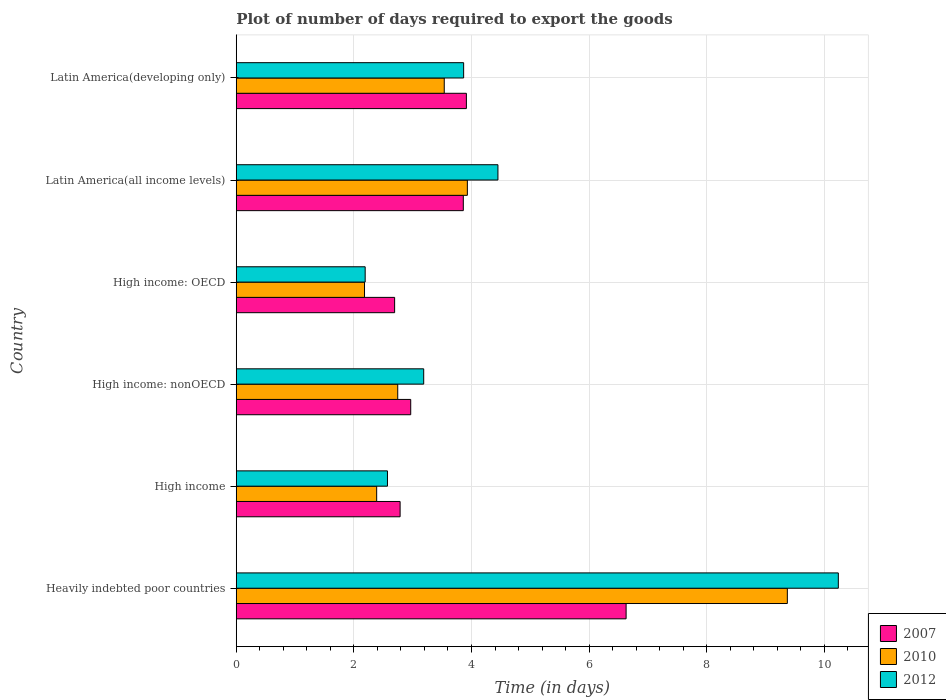How many groups of bars are there?
Make the answer very short. 6. Are the number of bars per tick equal to the number of legend labels?
Provide a short and direct response. Yes. What is the label of the 2nd group of bars from the top?
Your answer should be compact. Latin America(all income levels). What is the time required to export goods in 2012 in High income: nonOECD?
Offer a terse response. 3.19. Across all countries, what is the maximum time required to export goods in 2010?
Give a very brief answer. 9.37. Across all countries, what is the minimum time required to export goods in 2012?
Make the answer very short. 2.19. In which country was the time required to export goods in 2010 maximum?
Your response must be concise. Heavily indebted poor countries. In which country was the time required to export goods in 2010 minimum?
Your answer should be compact. High income: OECD. What is the total time required to export goods in 2010 in the graph?
Offer a terse response. 24.15. What is the difference between the time required to export goods in 2010 in Heavily indebted poor countries and that in Latin America(developing only)?
Make the answer very short. 5.83. What is the difference between the time required to export goods in 2012 in High income: OECD and the time required to export goods in 2007 in Latin America(all income levels)?
Keep it short and to the point. -1.67. What is the average time required to export goods in 2007 per country?
Keep it short and to the point. 3.81. What is the difference between the time required to export goods in 2010 and time required to export goods in 2007 in High income?
Your response must be concise. -0.4. What is the ratio of the time required to export goods in 2007 in High income to that in Latin America(developing only)?
Your response must be concise. 0.71. Is the time required to export goods in 2010 in High income: nonOECD less than that in Latin America(all income levels)?
Provide a succinct answer. Yes. What is the difference between the highest and the second highest time required to export goods in 2010?
Your answer should be compact. 5.44. What is the difference between the highest and the lowest time required to export goods in 2012?
Keep it short and to the point. 8.05. In how many countries, is the time required to export goods in 2010 greater than the average time required to export goods in 2010 taken over all countries?
Keep it short and to the point. 1. Is the sum of the time required to export goods in 2007 in Heavily indebted poor countries and Latin America(all income levels) greater than the maximum time required to export goods in 2010 across all countries?
Provide a succinct answer. Yes. What does the 2nd bar from the top in Latin America(developing only) represents?
Ensure brevity in your answer.  2010. Is it the case that in every country, the sum of the time required to export goods in 2012 and time required to export goods in 2007 is greater than the time required to export goods in 2010?
Keep it short and to the point. Yes. How many bars are there?
Offer a terse response. 18. Are the values on the major ticks of X-axis written in scientific E-notation?
Your answer should be very brief. No. Does the graph contain any zero values?
Ensure brevity in your answer.  No. Does the graph contain grids?
Provide a short and direct response. Yes. Where does the legend appear in the graph?
Make the answer very short. Bottom right. How are the legend labels stacked?
Your answer should be compact. Vertical. What is the title of the graph?
Make the answer very short. Plot of number of days required to export the goods. What is the label or title of the X-axis?
Your response must be concise. Time (in days). What is the label or title of the Y-axis?
Make the answer very short. Country. What is the Time (in days) of 2007 in Heavily indebted poor countries?
Provide a short and direct response. 6.63. What is the Time (in days) of 2010 in Heavily indebted poor countries?
Make the answer very short. 9.37. What is the Time (in days) of 2012 in Heavily indebted poor countries?
Provide a short and direct response. 10.24. What is the Time (in days) in 2007 in High income?
Your answer should be compact. 2.79. What is the Time (in days) in 2010 in High income?
Your answer should be compact. 2.39. What is the Time (in days) in 2012 in High income?
Provide a succinct answer. 2.57. What is the Time (in days) in 2007 in High income: nonOECD?
Ensure brevity in your answer.  2.97. What is the Time (in days) of 2010 in High income: nonOECD?
Your answer should be very brief. 2.75. What is the Time (in days) of 2012 in High income: nonOECD?
Offer a terse response. 3.19. What is the Time (in days) of 2007 in High income: OECD?
Provide a short and direct response. 2.69. What is the Time (in days) in 2010 in High income: OECD?
Offer a very short reply. 2.18. What is the Time (in days) of 2012 in High income: OECD?
Keep it short and to the point. 2.19. What is the Time (in days) of 2007 in Latin America(all income levels)?
Keep it short and to the point. 3.86. What is the Time (in days) of 2010 in Latin America(all income levels)?
Your response must be concise. 3.93. What is the Time (in days) in 2012 in Latin America(all income levels)?
Offer a terse response. 4.45. What is the Time (in days) of 2007 in Latin America(developing only)?
Give a very brief answer. 3.91. What is the Time (in days) of 2010 in Latin America(developing only)?
Offer a terse response. 3.54. What is the Time (in days) of 2012 in Latin America(developing only)?
Give a very brief answer. 3.87. Across all countries, what is the maximum Time (in days) of 2007?
Provide a succinct answer. 6.63. Across all countries, what is the maximum Time (in days) in 2010?
Give a very brief answer. 9.37. Across all countries, what is the maximum Time (in days) of 2012?
Offer a very short reply. 10.24. Across all countries, what is the minimum Time (in days) of 2007?
Keep it short and to the point. 2.69. Across all countries, what is the minimum Time (in days) in 2010?
Give a very brief answer. 2.18. Across all countries, what is the minimum Time (in days) of 2012?
Your answer should be very brief. 2.19. What is the total Time (in days) of 2007 in the graph?
Your answer should be compact. 22.85. What is the total Time (in days) in 2010 in the graph?
Ensure brevity in your answer.  24.15. What is the total Time (in days) of 2012 in the graph?
Make the answer very short. 26.51. What is the difference between the Time (in days) in 2007 in Heavily indebted poor countries and that in High income?
Ensure brevity in your answer.  3.84. What is the difference between the Time (in days) of 2010 in Heavily indebted poor countries and that in High income?
Make the answer very short. 6.98. What is the difference between the Time (in days) of 2012 in Heavily indebted poor countries and that in High income?
Ensure brevity in your answer.  7.67. What is the difference between the Time (in days) of 2007 in Heavily indebted poor countries and that in High income: nonOECD?
Ensure brevity in your answer.  3.66. What is the difference between the Time (in days) of 2010 in Heavily indebted poor countries and that in High income: nonOECD?
Keep it short and to the point. 6.63. What is the difference between the Time (in days) of 2012 in Heavily indebted poor countries and that in High income: nonOECD?
Your response must be concise. 7.05. What is the difference between the Time (in days) in 2007 in Heavily indebted poor countries and that in High income: OECD?
Provide a short and direct response. 3.94. What is the difference between the Time (in days) in 2010 in Heavily indebted poor countries and that in High income: OECD?
Give a very brief answer. 7.19. What is the difference between the Time (in days) of 2012 in Heavily indebted poor countries and that in High income: OECD?
Offer a very short reply. 8.05. What is the difference between the Time (in days) of 2007 in Heavily indebted poor countries and that in Latin America(all income levels)?
Keep it short and to the point. 2.77. What is the difference between the Time (in days) of 2010 in Heavily indebted poor countries and that in Latin America(all income levels)?
Your answer should be compact. 5.44. What is the difference between the Time (in days) of 2012 in Heavily indebted poor countries and that in Latin America(all income levels)?
Provide a short and direct response. 5.79. What is the difference between the Time (in days) in 2007 in Heavily indebted poor countries and that in Latin America(developing only)?
Give a very brief answer. 2.72. What is the difference between the Time (in days) in 2010 in Heavily indebted poor countries and that in Latin America(developing only)?
Provide a succinct answer. 5.83. What is the difference between the Time (in days) of 2012 in Heavily indebted poor countries and that in Latin America(developing only)?
Keep it short and to the point. 6.37. What is the difference between the Time (in days) of 2007 in High income and that in High income: nonOECD?
Give a very brief answer. -0.18. What is the difference between the Time (in days) in 2010 in High income and that in High income: nonOECD?
Your answer should be very brief. -0.36. What is the difference between the Time (in days) in 2012 in High income and that in High income: nonOECD?
Your answer should be compact. -0.62. What is the difference between the Time (in days) in 2007 in High income and that in High income: OECD?
Provide a short and direct response. 0.09. What is the difference between the Time (in days) in 2010 in High income and that in High income: OECD?
Keep it short and to the point. 0.21. What is the difference between the Time (in days) in 2012 in High income and that in High income: OECD?
Your response must be concise. 0.38. What is the difference between the Time (in days) of 2007 in High income and that in Latin America(all income levels)?
Your response must be concise. -1.07. What is the difference between the Time (in days) in 2010 in High income and that in Latin America(all income levels)?
Ensure brevity in your answer.  -1.54. What is the difference between the Time (in days) of 2012 in High income and that in Latin America(all income levels)?
Keep it short and to the point. -1.88. What is the difference between the Time (in days) in 2007 in High income and that in Latin America(developing only)?
Ensure brevity in your answer.  -1.13. What is the difference between the Time (in days) in 2010 in High income and that in Latin America(developing only)?
Offer a terse response. -1.15. What is the difference between the Time (in days) in 2012 in High income and that in Latin America(developing only)?
Ensure brevity in your answer.  -1.3. What is the difference between the Time (in days) of 2007 in High income: nonOECD and that in High income: OECD?
Ensure brevity in your answer.  0.27. What is the difference between the Time (in days) in 2010 in High income: nonOECD and that in High income: OECD?
Your response must be concise. 0.56. What is the difference between the Time (in days) in 2012 in High income: nonOECD and that in High income: OECD?
Provide a succinct answer. 1. What is the difference between the Time (in days) in 2007 in High income: nonOECD and that in Latin America(all income levels)?
Your response must be concise. -0.89. What is the difference between the Time (in days) in 2010 in High income: nonOECD and that in Latin America(all income levels)?
Make the answer very short. -1.18. What is the difference between the Time (in days) of 2012 in High income: nonOECD and that in Latin America(all income levels)?
Your response must be concise. -1.26. What is the difference between the Time (in days) in 2007 in High income: nonOECD and that in Latin America(developing only)?
Ensure brevity in your answer.  -0.95. What is the difference between the Time (in days) of 2010 in High income: nonOECD and that in Latin America(developing only)?
Provide a short and direct response. -0.79. What is the difference between the Time (in days) in 2012 in High income: nonOECD and that in Latin America(developing only)?
Give a very brief answer. -0.68. What is the difference between the Time (in days) of 2007 in High income: OECD and that in Latin America(all income levels)?
Give a very brief answer. -1.17. What is the difference between the Time (in days) of 2010 in High income: OECD and that in Latin America(all income levels)?
Make the answer very short. -1.75. What is the difference between the Time (in days) of 2012 in High income: OECD and that in Latin America(all income levels)?
Your response must be concise. -2.26. What is the difference between the Time (in days) of 2007 in High income: OECD and that in Latin America(developing only)?
Offer a terse response. -1.22. What is the difference between the Time (in days) in 2010 in High income: OECD and that in Latin America(developing only)?
Offer a terse response. -1.36. What is the difference between the Time (in days) of 2012 in High income: OECD and that in Latin America(developing only)?
Ensure brevity in your answer.  -1.67. What is the difference between the Time (in days) in 2007 in Latin America(all income levels) and that in Latin America(developing only)?
Give a very brief answer. -0.05. What is the difference between the Time (in days) in 2010 in Latin America(all income levels) and that in Latin America(developing only)?
Your answer should be very brief. 0.39. What is the difference between the Time (in days) in 2012 in Latin America(all income levels) and that in Latin America(developing only)?
Provide a short and direct response. 0.58. What is the difference between the Time (in days) of 2007 in Heavily indebted poor countries and the Time (in days) of 2010 in High income?
Ensure brevity in your answer.  4.24. What is the difference between the Time (in days) in 2007 in Heavily indebted poor countries and the Time (in days) in 2012 in High income?
Offer a terse response. 4.06. What is the difference between the Time (in days) in 2010 in Heavily indebted poor countries and the Time (in days) in 2012 in High income?
Keep it short and to the point. 6.8. What is the difference between the Time (in days) in 2007 in Heavily indebted poor countries and the Time (in days) in 2010 in High income: nonOECD?
Ensure brevity in your answer.  3.88. What is the difference between the Time (in days) in 2007 in Heavily indebted poor countries and the Time (in days) in 2012 in High income: nonOECD?
Your response must be concise. 3.44. What is the difference between the Time (in days) of 2010 in Heavily indebted poor countries and the Time (in days) of 2012 in High income: nonOECD?
Make the answer very short. 6.18. What is the difference between the Time (in days) in 2007 in Heavily indebted poor countries and the Time (in days) in 2010 in High income: OECD?
Your response must be concise. 4.45. What is the difference between the Time (in days) in 2007 in Heavily indebted poor countries and the Time (in days) in 2012 in High income: OECD?
Provide a short and direct response. 4.44. What is the difference between the Time (in days) in 2010 in Heavily indebted poor countries and the Time (in days) in 2012 in High income: OECD?
Keep it short and to the point. 7.18. What is the difference between the Time (in days) of 2007 in Heavily indebted poor countries and the Time (in days) of 2010 in Latin America(all income levels)?
Give a very brief answer. 2.7. What is the difference between the Time (in days) in 2007 in Heavily indebted poor countries and the Time (in days) in 2012 in Latin America(all income levels)?
Make the answer very short. 2.18. What is the difference between the Time (in days) in 2010 in Heavily indebted poor countries and the Time (in days) in 2012 in Latin America(all income levels)?
Provide a succinct answer. 4.92. What is the difference between the Time (in days) in 2007 in Heavily indebted poor countries and the Time (in days) in 2010 in Latin America(developing only)?
Keep it short and to the point. 3.09. What is the difference between the Time (in days) of 2007 in Heavily indebted poor countries and the Time (in days) of 2012 in Latin America(developing only)?
Make the answer very short. 2.76. What is the difference between the Time (in days) of 2010 in Heavily indebted poor countries and the Time (in days) of 2012 in Latin America(developing only)?
Your response must be concise. 5.5. What is the difference between the Time (in days) of 2007 in High income and the Time (in days) of 2010 in High income: nonOECD?
Your answer should be compact. 0.04. What is the difference between the Time (in days) of 2007 in High income and the Time (in days) of 2012 in High income: nonOECD?
Provide a short and direct response. -0.4. What is the difference between the Time (in days) in 2010 in High income and the Time (in days) in 2012 in High income: nonOECD?
Keep it short and to the point. -0.8. What is the difference between the Time (in days) in 2007 in High income and the Time (in days) in 2010 in High income: OECD?
Ensure brevity in your answer.  0.61. What is the difference between the Time (in days) of 2007 in High income and the Time (in days) of 2012 in High income: OECD?
Ensure brevity in your answer.  0.59. What is the difference between the Time (in days) of 2010 in High income and the Time (in days) of 2012 in High income: OECD?
Your answer should be very brief. 0.2. What is the difference between the Time (in days) in 2007 in High income and the Time (in days) in 2010 in Latin America(all income levels)?
Offer a terse response. -1.14. What is the difference between the Time (in days) of 2007 in High income and the Time (in days) of 2012 in Latin America(all income levels)?
Provide a succinct answer. -1.66. What is the difference between the Time (in days) of 2010 in High income and the Time (in days) of 2012 in Latin America(all income levels)?
Offer a terse response. -2.06. What is the difference between the Time (in days) of 2007 in High income and the Time (in days) of 2010 in Latin America(developing only)?
Provide a succinct answer. -0.75. What is the difference between the Time (in days) of 2007 in High income and the Time (in days) of 2012 in Latin America(developing only)?
Make the answer very short. -1.08. What is the difference between the Time (in days) in 2010 in High income and the Time (in days) in 2012 in Latin America(developing only)?
Provide a succinct answer. -1.48. What is the difference between the Time (in days) of 2007 in High income: nonOECD and the Time (in days) of 2010 in High income: OECD?
Offer a terse response. 0.79. What is the difference between the Time (in days) of 2007 in High income: nonOECD and the Time (in days) of 2012 in High income: OECD?
Offer a very short reply. 0.77. What is the difference between the Time (in days) in 2010 in High income: nonOECD and the Time (in days) in 2012 in High income: OECD?
Your answer should be very brief. 0.55. What is the difference between the Time (in days) of 2007 in High income: nonOECD and the Time (in days) of 2010 in Latin America(all income levels)?
Give a very brief answer. -0.96. What is the difference between the Time (in days) in 2007 in High income: nonOECD and the Time (in days) in 2012 in Latin America(all income levels)?
Provide a succinct answer. -1.48. What is the difference between the Time (in days) in 2010 in High income: nonOECD and the Time (in days) in 2012 in Latin America(all income levels)?
Ensure brevity in your answer.  -1.7. What is the difference between the Time (in days) in 2007 in High income: nonOECD and the Time (in days) in 2010 in Latin America(developing only)?
Provide a succinct answer. -0.57. What is the difference between the Time (in days) in 2007 in High income: nonOECD and the Time (in days) in 2012 in Latin America(developing only)?
Your answer should be very brief. -0.9. What is the difference between the Time (in days) in 2010 in High income: nonOECD and the Time (in days) in 2012 in Latin America(developing only)?
Your response must be concise. -1.12. What is the difference between the Time (in days) of 2007 in High income: OECD and the Time (in days) of 2010 in Latin America(all income levels)?
Give a very brief answer. -1.24. What is the difference between the Time (in days) of 2007 in High income: OECD and the Time (in days) of 2012 in Latin America(all income levels)?
Give a very brief answer. -1.76. What is the difference between the Time (in days) in 2010 in High income: OECD and the Time (in days) in 2012 in Latin America(all income levels)?
Offer a terse response. -2.27. What is the difference between the Time (in days) in 2007 in High income: OECD and the Time (in days) in 2010 in Latin America(developing only)?
Your answer should be compact. -0.84. What is the difference between the Time (in days) of 2007 in High income: OECD and the Time (in days) of 2012 in Latin America(developing only)?
Ensure brevity in your answer.  -1.17. What is the difference between the Time (in days) in 2010 in High income: OECD and the Time (in days) in 2012 in Latin America(developing only)?
Offer a very short reply. -1.69. What is the difference between the Time (in days) of 2007 in Latin America(all income levels) and the Time (in days) of 2010 in Latin America(developing only)?
Keep it short and to the point. 0.32. What is the difference between the Time (in days) of 2007 in Latin America(all income levels) and the Time (in days) of 2012 in Latin America(developing only)?
Ensure brevity in your answer.  -0.01. What is the difference between the Time (in days) in 2010 in Latin America(all income levels) and the Time (in days) in 2012 in Latin America(developing only)?
Your answer should be very brief. 0.06. What is the average Time (in days) in 2007 per country?
Provide a short and direct response. 3.81. What is the average Time (in days) of 2010 per country?
Provide a succinct answer. 4.03. What is the average Time (in days) in 2012 per country?
Offer a terse response. 4.42. What is the difference between the Time (in days) in 2007 and Time (in days) in 2010 in Heavily indebted poor countries?
Provide a succinct answer. -2.74. What is the difference between the Time (in days) of 2007 and Time (in days) of 2012 in Heavily indebted poor countries?
Ensure brevity in your answer.  -3.61. What is the difference between the Time (in days) of 2010 and Time (in days) of 2012 in Heavily indebted poor countries?
Provide a succinct answer. -0.87. What is the difference between the Time (in days) of 2007 and Time (in days) of 2010 in High income?
Your answer should be compact. 0.4. What is the difference between the Time (in days) in 2007 and Time (in days) in 2012 in High income?
Offer a terse response. 0.21. What is the difference between the Time (in days) in 2010 and Time (in days) in 2012 in High income?
Offer a terse response. -0.18. What is the difference between the Time (in days) of 2007 and Time (in days) of 2010 in High income: nonOECD?
Your answer should be very brief. 0.22. What is the difference between the Time (in days) in 2007 and Time (in days) in 2012 in High income: nonOECD?
Give a very brief answer. -0.22. What is the difference between the Time (in days) of 2010 and Time (in days) of 2012 in High income: nonOECD?
Offer a terse response. -0.44. What is the difference between the Time (in days) of 2007 and Time (in days) of 2010 in High income: OECD?
Your answer should be very brief. 0.51. What is the difference between the Time (in days) of 2007 and Time (in days) of 2012 in High income: OECD?
Keep it short and to the point. 0.5. What is the difference between the Time (in days) of 2010 and Time (in days) of 2012 in High income: OECD?
Your answer should be compact. -0.01. What is the difference between the Time (in days) in 2007 and Time (in days) in 2010 in Latin America(all income levels)?
Keep it short and to the point. -0.07. What is the difference between the Time (in days) in 2007 and Time (in days) in 2012 in Latin America(all income levels)?
Your answer should be very brief. -0.59. What is the difference between the Time (in days) of 2010 and Time (in days) of 2012 in Latin America(all income levels)?
Provide a succinct answer. -0.52. What is the difference between the Time (in days) of 2007 and Time (in days) of 2010 in Latin America(developing only)?
Provide a succinct answer. 0.38. What is the difference between the Time (in days) in 2007 and Time (in days) in 2012 in Latin America(developing only)?
Ensure brevity in your answer.  0.05. What is the difference between the Time (in days) in 2010 and Time (in days) in 2012 in Latin America(developing only)?
Offer a very short reply. -0.33. What is the ratio of the Time (in days) in 2007 in Heavily indebted poor countries to that in High income?
Your answer should be compact. 2.38. What is the ratio of the Time (in days) of 2010 in Heavily indebted poor countries to that in High income?
Make the answer very short. 3.92. What is the ratio of the Time (in days) of 2012 in Heavily indebted poor countries to that in High income?
Your answer should be very brief. 3.98. What is the ratio of the Time (in days) of 2007 in Heavily indebted poor countries to that in High income: nonOECD?
Provide a succinct answer. 2.23. What is the ratio of the Time (in days) of 2010 in Heavily indebted poor countries to that in High income: nonOECD?
Make the answer very short. 3.41. What is the ratio of the Time (in days) of 2012 in Heavily indebted poor countries to that in High income: nonOECD?
Give a very brief answer. 3.21. What is the ratio of the Time (in days) of 2007 in Heavily indebted poor countries to that in High income: OECD?
Your answer should be very brief. 2.46. What is the ratio of the Time (in days) of 2010 in Heavily indebted poor countries to that in High income: OECD?
Ensure brevity in your answer.  4.3. What is the ratio of the Time (in days) in 2012 in Heavily indebted poor countries to that in High income: OECD?
Provide a succinct answer. 4.67. What is the ratio of the Time (in days) of 2007 in Heavily indebted poor countries to that in Latin America(all income levels)?
Ensure brevity in your answer.  1.72. What is the ratio of the Time (in days) in 2010 in Heavily indebted poor countries to that in Latin America(all income levels)?
Make the answer very short. 2.38. What is the ratio of the Time (in days) in 2012 in Heavily indebted poor countries to that in Latin America(all income levels)?
Your answer should be very brief. 2.3. What is the ratio of the Time (in days) in 2007 in Heavily indebted poor countries to that in Latin America(developing only)?
Give a very brief answer. 1.69. What is the ratio of the Time (in days) of 2010 in Heavily indebted poor countries to that in Latin America(developing only)?
Provide a succinct answer. 2.65. What is the ratio of the Time (in days) in 2012 in Heavily indebted poor countries to that in Latin America(developing only)?
Keep it short and to the point. 2.65. What is the ratio of the Time (in days) in 2007 in High income to that in High income: nonOECD?
Give a very brief answer. 0.94. What is the ratio of the Time (in days) in 2010 in High income to that in High income: nonOECD?
Provide a short and direct response. 0.87. What is the ratio of the Time (in days) in 2012 in High income to that in High income: nonOECD?
Offer a very short reply. 0.81. What is the ratio of the Time (in days) of 2007 in High income to that in High income: OECD?
Offer a very short reply. 1.03. What is the ratio of the Time (in days) in 2010 in High income to that in High income: OECD?
Your response must be concise. 1.09. What is the ratio of the Time (in days) in 2012 in High income to that in High income: OECD?
Provide a succinct answer. 1.17. What is the ratio of the Time (in days) of 2007 in High income to that in Latin America(all income levels)?
Offer a very short reply. 0.72. What is the ratio of the Time (in days) of 2010 in High income to that in Latin America(all income levels)?
Your answer should be very brief. 0.61. What is the ratio of the Time (in days) of 2012 in High income to that in Latin America(all income levels)?
Ensure brevity in your answer.  0.58. What is the ratio of the Time (in days) of 2007 in High income to that in Latin America(developing only)?
Make the answer very short. 0.71. What is the ratio of the Time (in days) of 2010 in High income to that in Latin America(developing only)?
Offer a very short reply. 0.68. What is the ratio of the Time (in days) of 2012 in High income to that in Latin America(developing only)?
Keep it short and to the point. 0.67. What is the ratio of the Time (in days) of 2007 in High income: nonOECD to that in High income: OECD?
Provide a succinct answer. 1.1. What is the ratio of the Time (in days) in 2010 in High income: nonOECD to that in High income: OECD?
Ensure brevity in your answer.  1.26. What is the ratio of the Time (in days) of 2012 in High income: nonOECD to that in High income: OECD?
Your response must be concise. 1.45. What is the ratio of the Time (in days) in 2007 in High income: nonOECD to that in Latin America(all income levels)?
Make the answer very short. 0.77. What is the ratio of the Time (in days) in 2010 in High income: nonOECD to that in Latin America(all income levels)?
Keep it short and to the point. 0.7. What is the ratio of the Time (in days) of 2012 in High income: nonOECD to that in Latin America(all income levels)?
Provide a short and direct response. 0.72. What is the ratio of the Time (in days) of 2007 in High income: nonOECD to that in Latin America(developing only)?
Your response must be concise. 0.76. What is the ratio of the Time (in days) of 2010 in High income: nonOECD to that in Latin America(developing only)?
Provide a short and direct response. 0.78. What is the ratio of the Time (in days) of 2012 in High income: nonOECD to that in Latin America(developing only)?
Provide a succinct answer. 0.82. What is the ratio of the Time (in days) of 2007 in High income: OECD to that in Latin America(all income levels)?
Your response must be concise. 0.7. What is the ratio of the Time (in days) of 2010 in High income: OECD to that in Latin America(all income levels)?
Your answer should be very brief. 0.56. What is the ratio of the Time (in days) of 2012 in High income: OECD to that in Latin America(all income levels)?
Give a very brief answer. 0.49. What is the ratio of the Time (in days) of 2007 in High income: OECD to that in Latin America(developing only)?
Provide a short and direct response. 0.69. What is the ratio of the Time (in days) in 2010 in High income: OECD to that in Latin America(developing only)?
Provide a succinct answer. 0.62. What is the ratio of the Time (in days) in 2012 in High income: OECD to that in Latin America(developing only)?
Offer a terse response. 0.57. What is the ratio of the Time (in days) in 2007 in Latin America(all income levels) to that in Latin America(developing only)?
Provide a succinct answer. 0.99. What is the ratio of the Time (in days) in 2012 in Latin America(all income levels) to that in Latin America(developing only)?
Keep it short and to the point. 1.15. What is the difference between the highest and the second highest Time (in days) in 2007?
Your answer should be compact. 2.72. What is the difference between the highest and the second highest Time (in days) in 2010?
Provide a succinct answer. 5.44. What is the difference between the highest and the second highest Time (in days) of 2012?
Your answer should be very brief. 5.79. What is the difference between the highest and the lowest Time (in days) of 2007?
Offer a terse response. 3.94. What is the difference between the highest and the lowest Time (in days) of 2010?
Ensure brevity in your answer.  7.19. What is the difference between the highest and the lowest Time (in days) of 2012?
Provide a short and direct response. 8.05. 